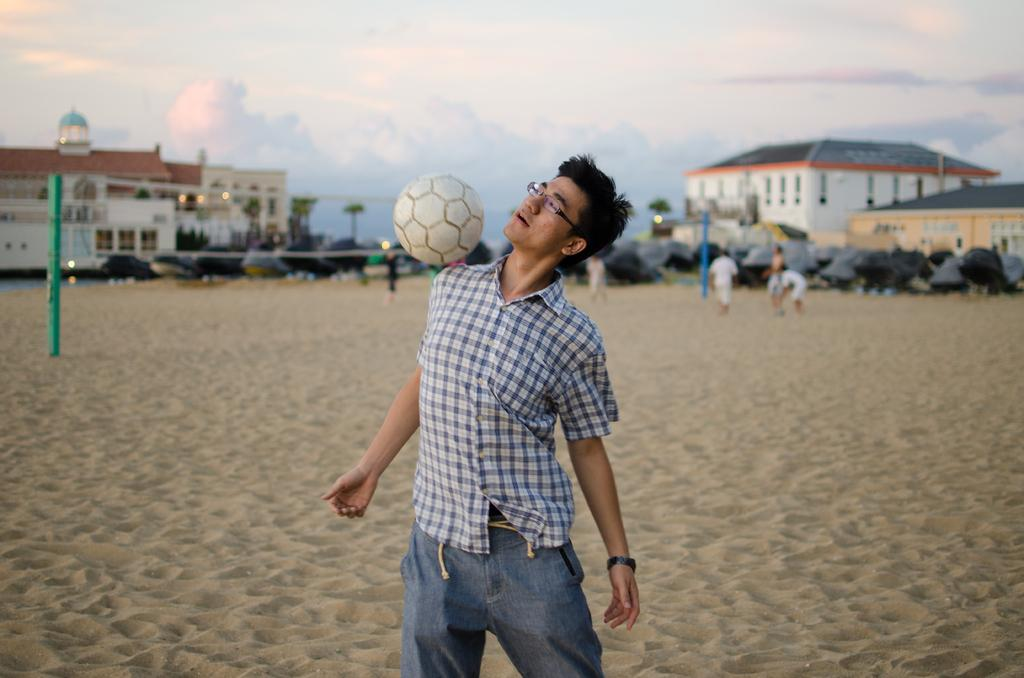What is the main subject of the image? There is a person standing in the image. What is located above the person? There is a ball above the person. What is behind the person? There is a net behind the person. Are there any other people in the image? Yes, there are other people standing at the back. What can be seen in the background of the image? Buildings are visible in the background. What type of religious ceremony is taking place in the image? There is no indication of a religious ceremony in the image; it features a person standing with a ball and net, suggesting a sports-related context. Can you describe the form of the seashore visible in the image? There is no seashore visible in the image; it features buildings in the background, not a coastal landscape. 